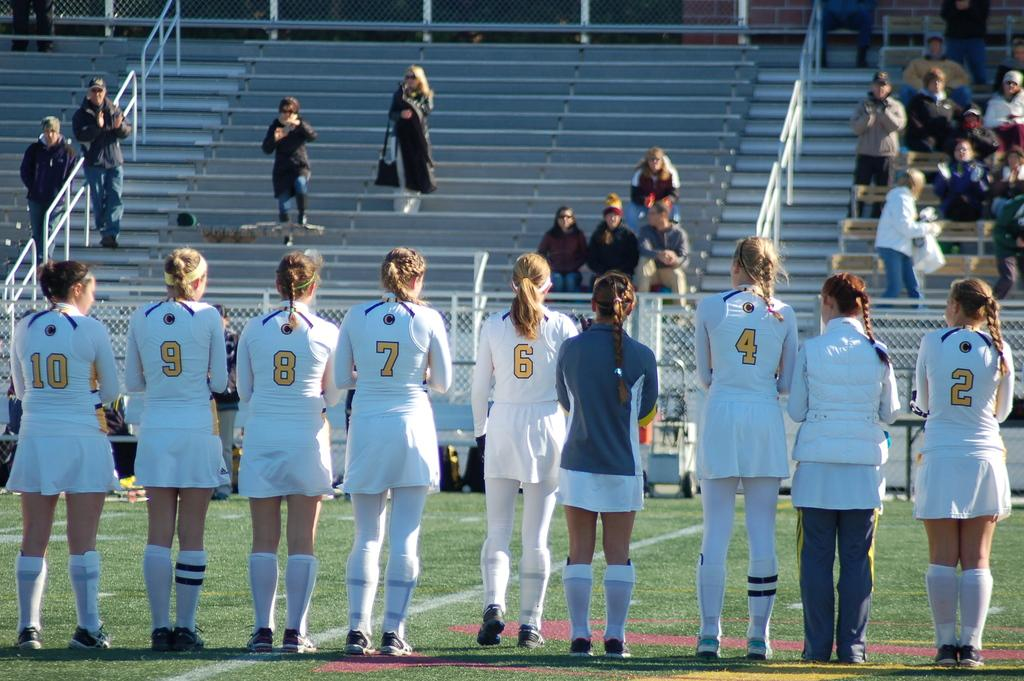Provide a one-sentence caption for the provided image. A line of female players wearing white jerseys stand on the field with numbers 10 and 2 on the ends. 